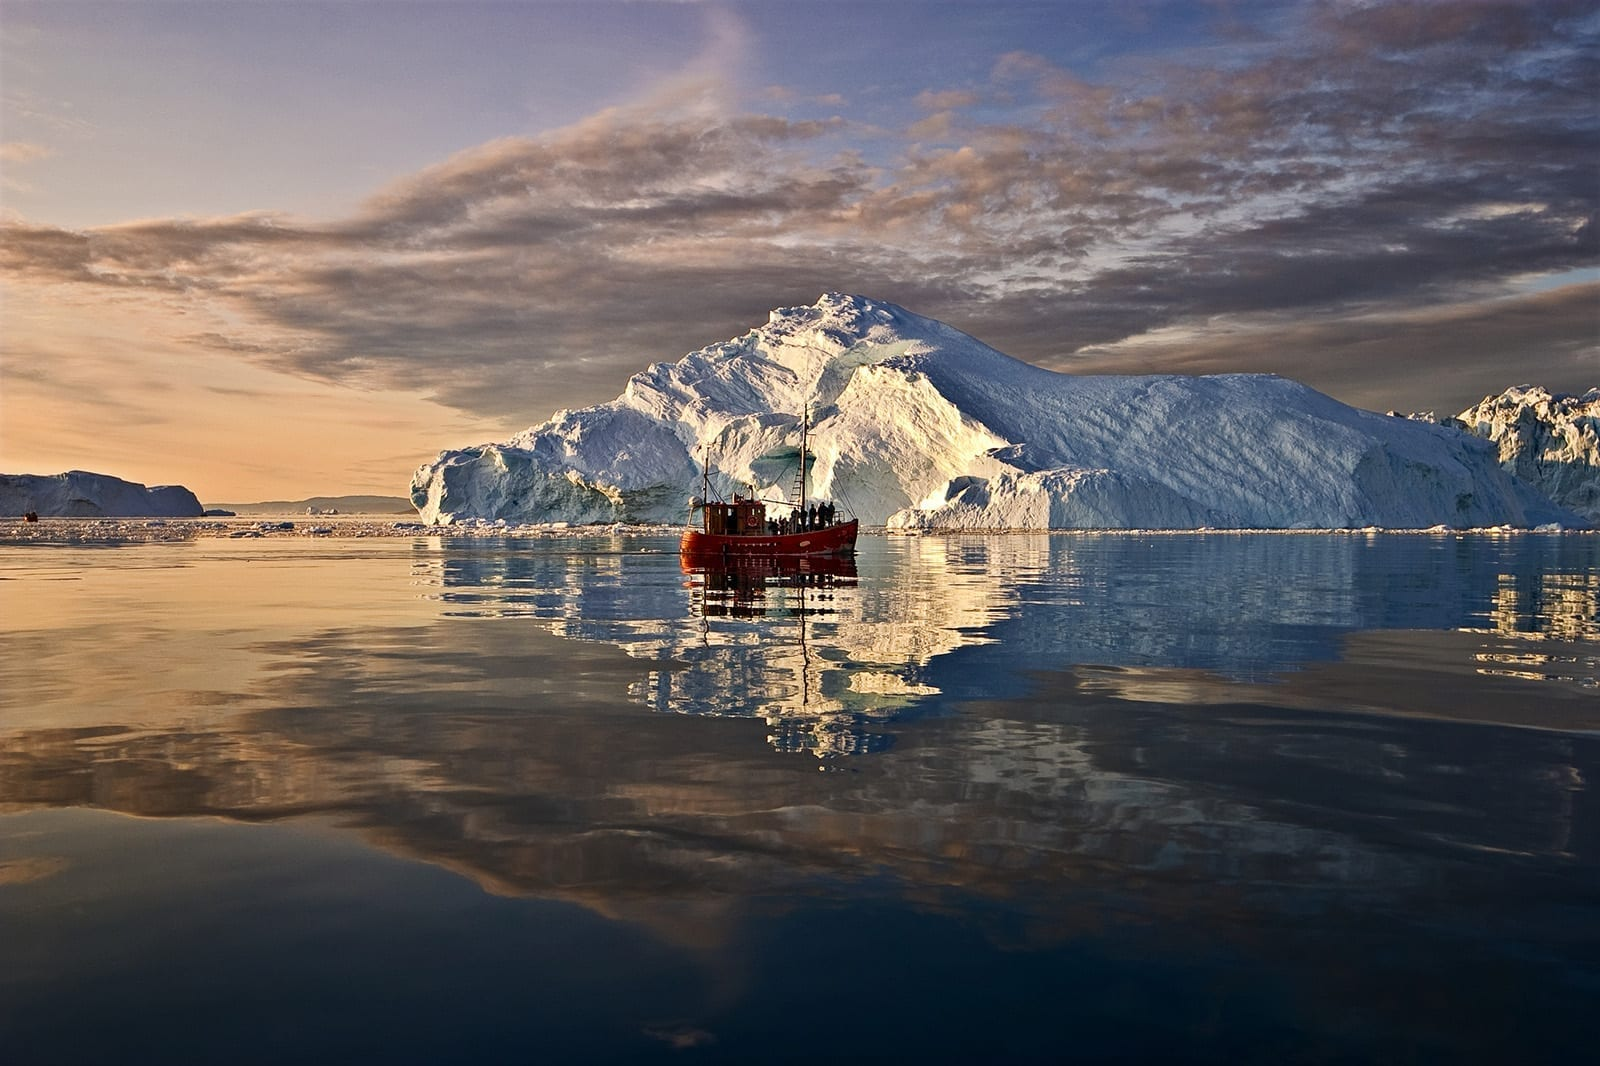Imagine if this scene took place a hundred years ago. How might it have been different? If we were looking at this scene a century ago, there might be notable differences due to climate variations. The icebergs might have appeared even larger and more numerous, as the rate of ice calving could have been slower without the modern extent of global warming. The absence of a modern boat also indicates that human interaction with such remote areas was less frequent, and such an expedition would have been reserved for only the most intrepid explorers or local Inuit communities. The scene would still be awe-inspiring, but perhaps less accessible to the world, with its stories and significance held closely by those who could witness it firsthand. 